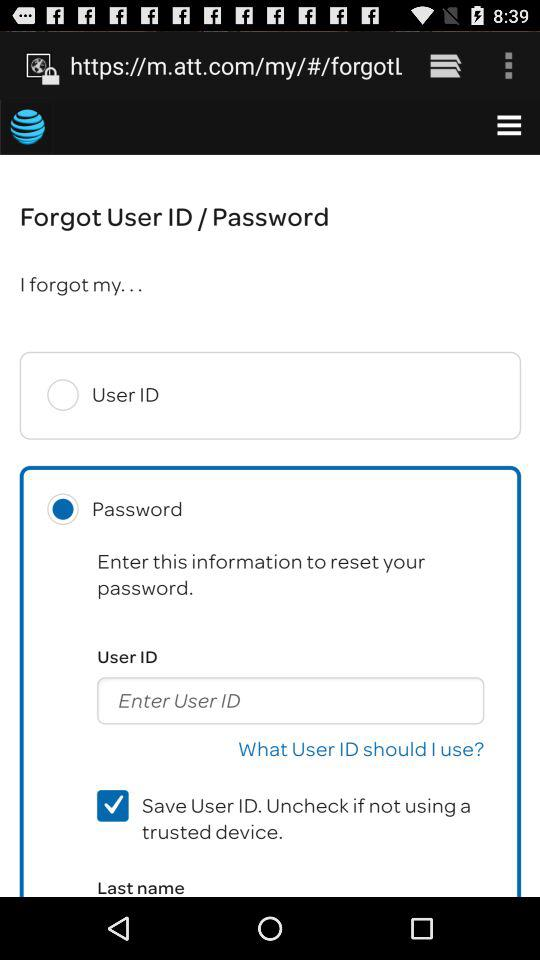How many text inputs are there for entering information?
Answer the question using a single word or phrase. 2 